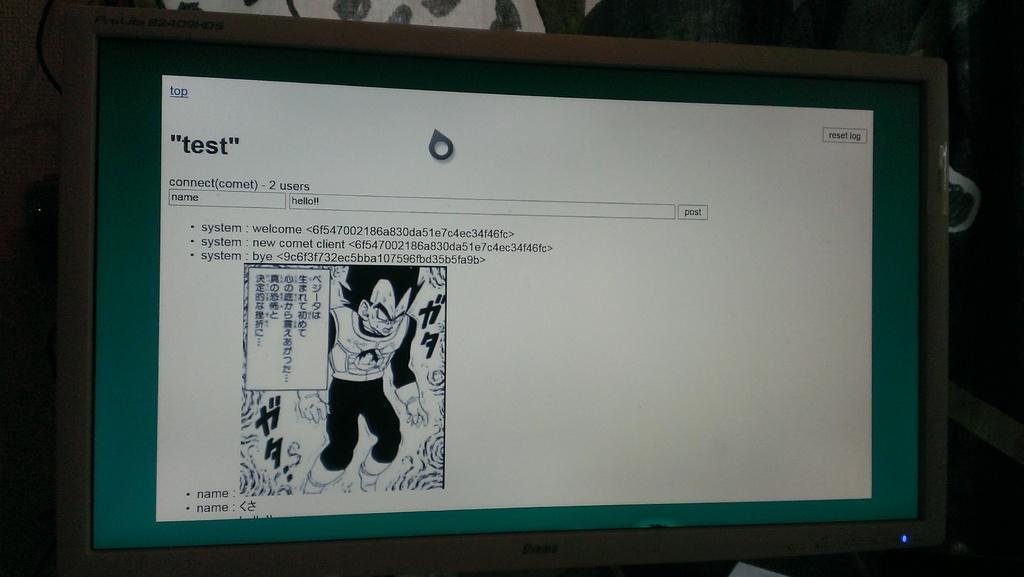<image>
Write a terse but informative summary of the picture. The computer monitor is showing a test site with the image of an animated character. 